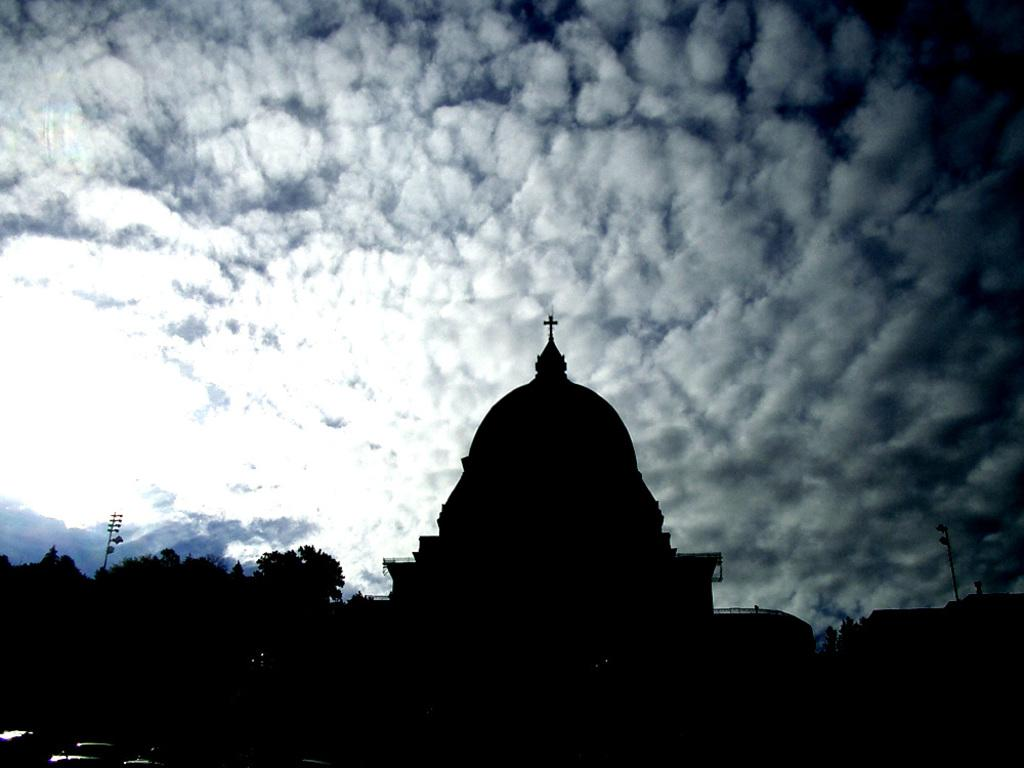What is the main structure in the center of the image? There is a church in the center of the image. What can be seen on the left side of the image? There are trees and a pole on the left side of the image. What is visible at the top of the image? The sky is visible at the top of the image. What type of trouble is the dad experiencing with the brick in the image? There is no dad or brick present in the image, so it is not possible to answer that question. 